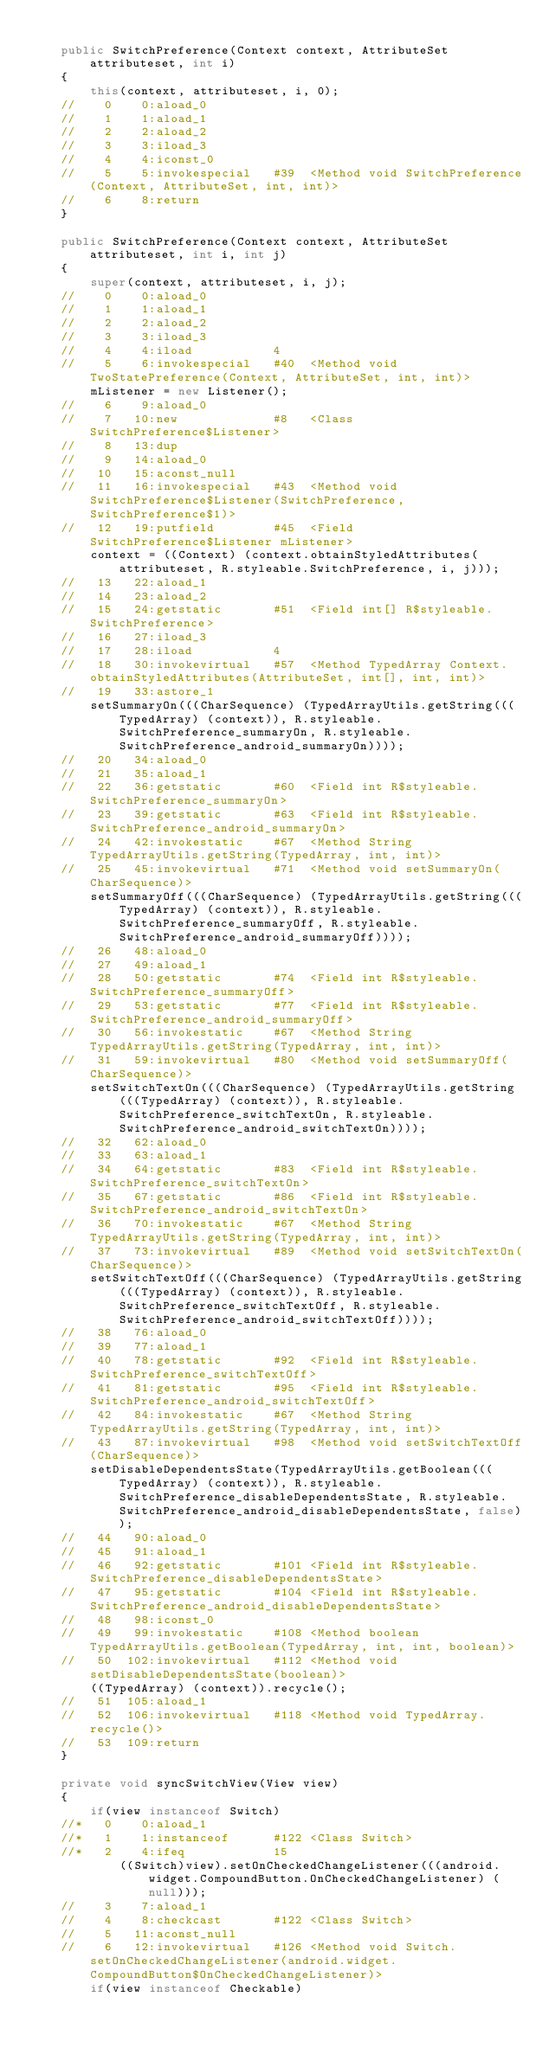Convert code to text. <code><loc_0><loc_0><loc_500><loc_500><_Java_>
	public SwitchPreference(Context context, AttributeSet attributeset, int i)
	{
		this(context, attributeset, i, 0);
	//    0    0:aload_0         
	//    1    1:aload_1         
	//    2    2:aload_2         
	//    3    3:iload_3         
	//    4    4:iconst_0        
	//    5    5:invokespecial   #39  <Method void SwitchPreference(Context, AttributeSet, int, int)>
	//    6    8:return          
	}

	public SwitchPreference(Context context, AttributeSet attributeset, int i, int j)
	{
		super(context, attributeset, i, j);
	//    0    0:aload_0         
	//    1    1:aload_1         
	//    2    2:aload_2         
	//    3    3:iload_3         
	//    4    4:iload           4
	//    5    6:invokespecial   #40  <Method void TwoStatePreference(Context, AttributeSet, int, int)>
		mListener = new Listener();
	//    6    9:aload_0         
	//    7   10:new             #8   <Class SwitchPreference$Listener>
	//    8   13:dup             
	//    9   14:aload_0         
	//   10   15:aconst_null     
	//   11   16:invokespecial   #43  <Method void SwitchPreference$Listener(SwitchPreference, SwitchPreference$1)>
	//   12   19:putfield        #45  <Field SwitchPreference$Listener mListener>
		context = ((Context) (context.obtainStyledAttributes(attributeset, R.styleable.SwitchPreference, i, j)));
	//   13   22:aload_1         
	//   14   23:aload_2         
	//   15   24:getstatic       #51  <Field int[] R$styleable.SwitchPreference>
	//   16   27:iload_3         
	//   17   28:iload           4
	//   18   30:invokevirtual   #57  <Method TypedArray Context.obtainStyledAttributes(AttributeSet, int[], int, int)>
	//   19   33:astore_1        
		setSummaryOn(((CharSequence) (TypedArrayUtils.getString(((TypedArray) (context)), R.styleable.SwitchPreference_summaryOn, R.styleable.SwitchPreference_android_summaryOn))));
	//   20   34:aload_0         
	//   21   35:aload_1         
	//   22   36:getstatic       #60  <Field int R$styleable.SwitchPreference_summaryOn>
	//   23   39:getstatic       #63  <Field int R$styleable.SwitchPreference_android_summaryOn>
	//   24   42:invokestatic    #67  <Method String TypedArrayUtils.getString(TypedArray, int, int)>
	//   25   45:invokevirtual   #71  <Method void setSummaryOn(CharSequence)>
		setSummaryOff(((CharSequence) (TypedArrayUtils.getString(((TypedArray) (context)), R.styleable.SwitchPreference_summaryOff, R.styleable.SwitchPreference_android_summaryOff))));
	//   26   48:aload_0         
	//   27   49:aload_1         
	//   28   50:getstatic       #74  <Field int R$styleable.SwitchPreference_summaryOff>
	//   29   53:getstatic       #77  <Field int R$styleable.SwitchPreference_android_summaryOff>
	//   30   56:invokestatic    #67  <Method String TypedArrayUtils.getString(TypedArray, int, int)>
	//   31   59:invokevirtual   #80  <Method void setSummaryOff(CharSequence)>
		setSwitchTextOn(((CharSequence) (TypedArrayUtils.getString(((TypedArray) (context)), R.styleable.SwitchPreference_switchTextOn, R.styleable.SwitchPreference_android_switchTextOn))));
	//   32   62:aload_0         
	//   33   63:aload_1         
	//   34   64:getstatic       #83  <Field int R$styleable.SwitchPreference_switchTextOn>
	//   35   67:getstatic       #86  <Field int R$styleable.SwitchPreference_android_switchTextOn>
	//   36   70:invokestatic    #67  <Method String TypedArrayUtils.getString(TypedArray, int, int)>
	//   37   73:invokevirtual   #89  <Method void setSwitchTextOn(CharSequence)>
		setSwitchTextOff(((CharSequence) (TypedArrayUtils.getString(((TypedArray) (context)), R.styleable.SwitchPreference_switchTextOff, R.styleable.SwitchPreference_android_switchTextOff))));
	//   38   76:aload_0         
	//   39   77:aload_1         
	//   40   78:getstatic       #92  <Field int R$styleable.SwitchPreference_switchTextOff>
	//   41   81:getstatic       #95  <Field int R$styleable.SwitchPreference_android_switchTextOff>
	//   42   84:invokestatic    #67  <Method String TypedArrayUtils.getString(TypedArray, int, int)>
	//   43   87:invokevirtual   #98  <Method void setSwitchTextOff(CharSequence)>
		setDisableDependentsState(TypedArrayUtils.getBoolean(((TypedArray) (context)), R.styleable.SwitchPreference_disableDependentsState, R.styleable.SwitchPreference_android_disableDependentsState, false));
	//   44   90:aload_0         
	//   45   91:aload_1         
	//   46   92:getstatic       #101 <Field int R$styleable.SwitchPreference_disableDependentsState>
	//   47   95:getstatic       #104 <Field int R$styleable.SwitchPreference_android_disableDependentsState>
	//   48   98:iconst_0        
	//   49   99:invokestatic    #108 <Method boolean TypedArrayUtils.getBoolean(TypedArray, int, int, boolean)>
	//   50  102:invokevirtual   #112 <Method void setDisableDependentsState(boolean)>
		((TypedArray) (context)).recycle();
	//   51  105:aload_1         
	//   52  106:invokevirtual   #118 <Method void TypedArray.recycle()>
	//   53  109:return          
	}

	private void syncSwitchView(View view)
	{
		if(view instanceof Switch)
	//*   0    0:aload_1         
	//*   1    1:instanceof      #122 <Class Switch>
	//*   2    4:ifeq            15
			((Switch)view).setOnCheckedChangeListener(((android.widget.CompoundButton.OnCheckedChangeListener) (null)));
	//    3    7:aload_1         
	//    4    8:checkcast       #122 <Class Switch>
	//    5   11:aconst_null     
	//    6   12:invokevirtual   #126 <Method void Switch.setOnCheckedChangeListener(android.widget.CompoundButton$OnCheckedChangeListener)>
		if(view instanceof Checkable)</code> 